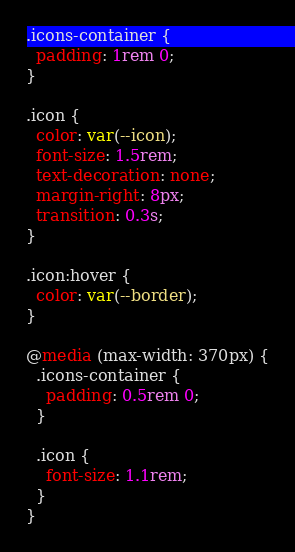<code> <loc_0><loc_0><loc_500><loc_500><_CSS_>.icons-container {
  padding: 1rem 0;
}

.icon {
  color: var(--icon);
  font-size: 1.5rem;
  text-decoration: none;
  margin-right: 8px;
  transition: 0.3s;
}

.icon:hover {
  color: var(--border);
}

@media (max-width: 370px) {
  .icons-container {
    padding: 0.5rem 0;
  }

  .icon {
    font-size: 1.1rem;
  }
}
</code> 